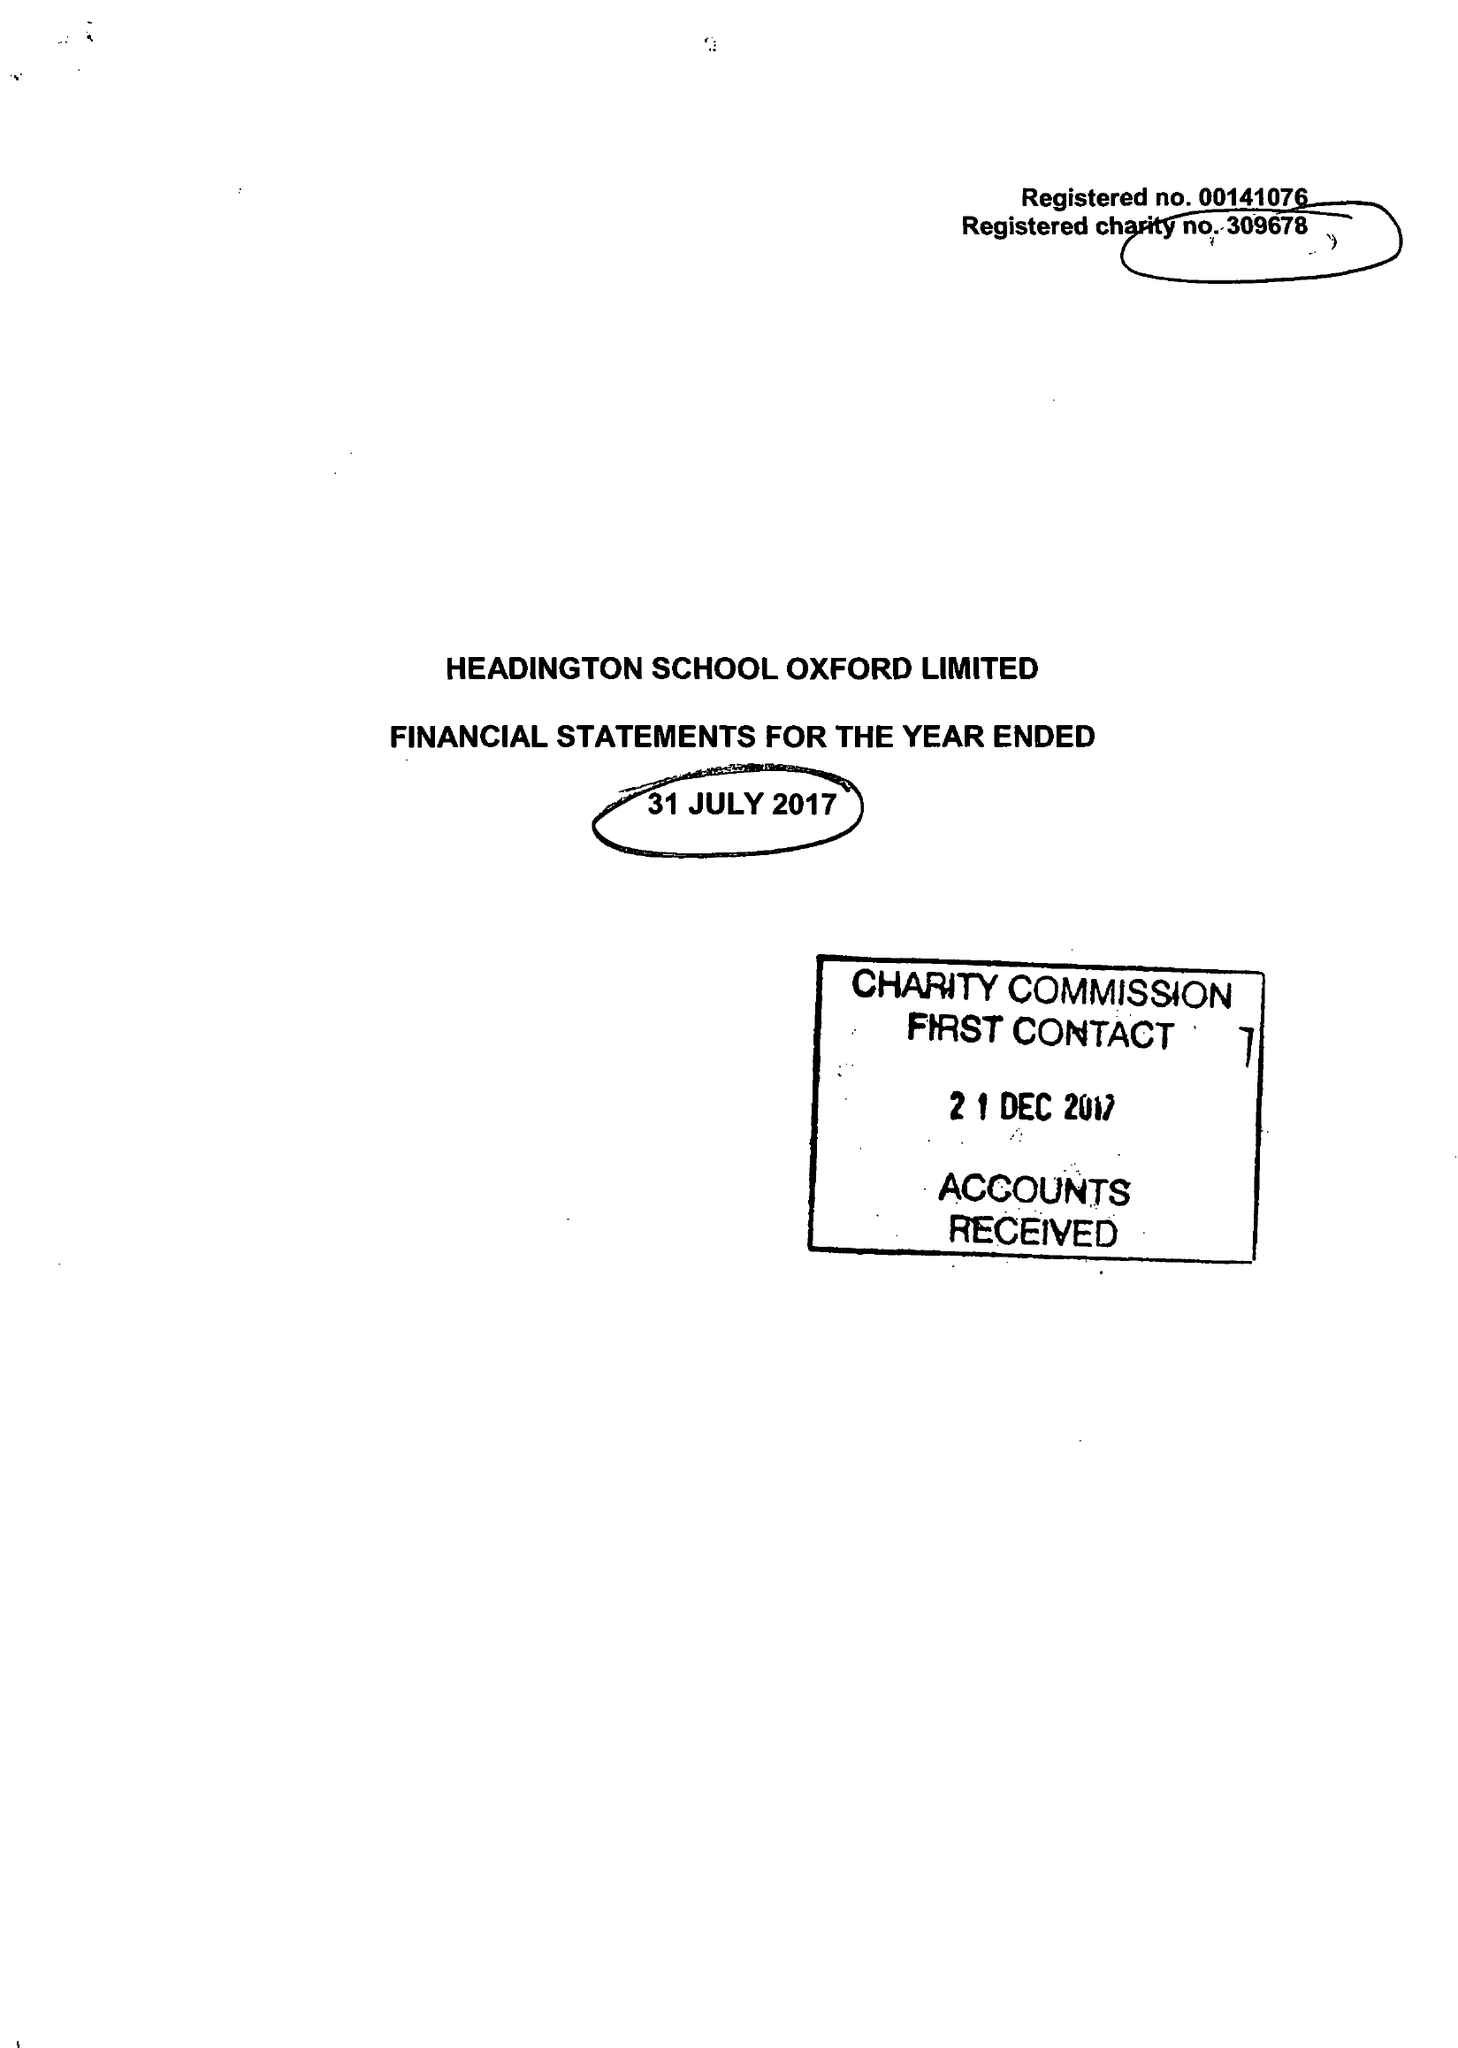What is the value for the income_annually_in_british_pounds?
Answer the question using a single word or phrase. 20915221.00 